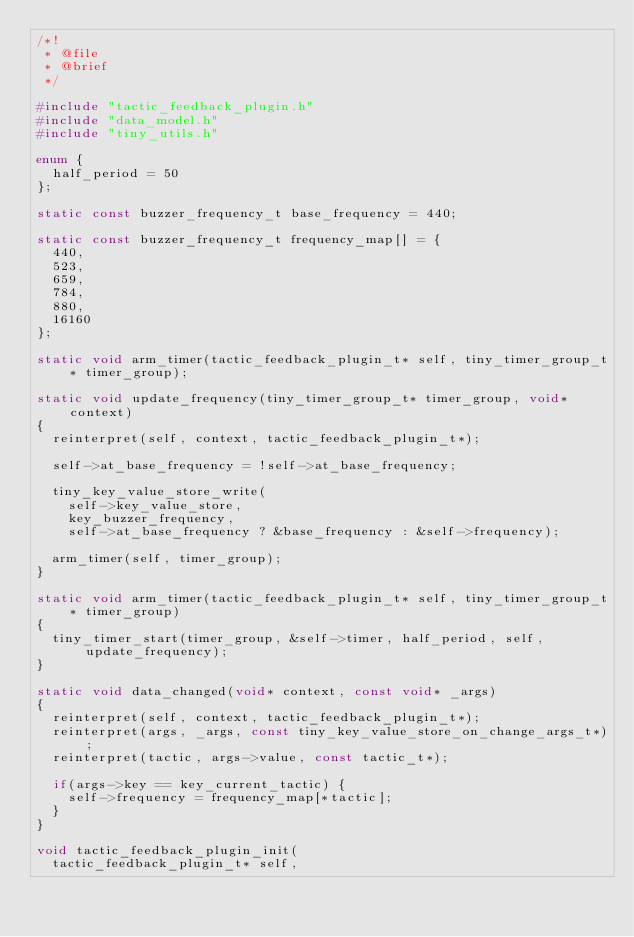Convert code to text. <code><loc_0><loc_0><loc_500><loc_500><_C_>/*!
 * @file
 * @brief
 */

#include "tactic_feedback_plugin.h"
#include "data_model.h"
#include "tiny_utils.h"

enum {
  half_period = 50
};

static const buzzer_frequency_t base_frequency = 440;

static const buzzer_frequency_t frequency_map[] = {
  440,
  523,
  659,
  784,
  880,
  16160
};

static void arm_timer(tactic_feedback_plugin_t* self, tiny_timer_group_t* timer_group);

static void update_frequency(tiny_timer_group_t* timer_group, void* context)
{
  reinterpret(self, context, tactic_feedback_plugin_t*);

  self->at_base_frequency = !self->at_base_frequency;

  tiny_key_value_store_write(
    self->key_value_store,
    key_buzzer_frequency,
    self->at_base_frequency ? &base_frequency : &self->frequency);

  arm_timer(self, timer_group);
}

static void arm_timer(tactic_feedback_plugin_t* self, tiny_timer_group_t* timer_group)
{
  tiny_timer_start(timer_group, &self->timer, half_period, self, update_frequency);
}

static void data_changed(void* context, const void* _args)
{
  reinterpret(self, context, tactic_feedback_plugin_t*);
  reinterpret(args, _args, const tiny_key_value_store_on_change_args_t*);
  reinterpret(tactic, args->value, const tactic_t*);

  if(args->key == key_current_tactic) {
    self->frequency = frequency_map[*tactic];
  }
}

void tactic_feedback_plugin_init(
  tactic_feedback_plugin_t* self,</code> 